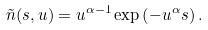Convert formula to latex. <formula><loc_0><loc_0><loc_500><loc_500>\tilde { n } ( s , u ) = u ^ { \alpha - 1 } \exp \left ( - u ^ { \alpha } s \right ) .</formula> 